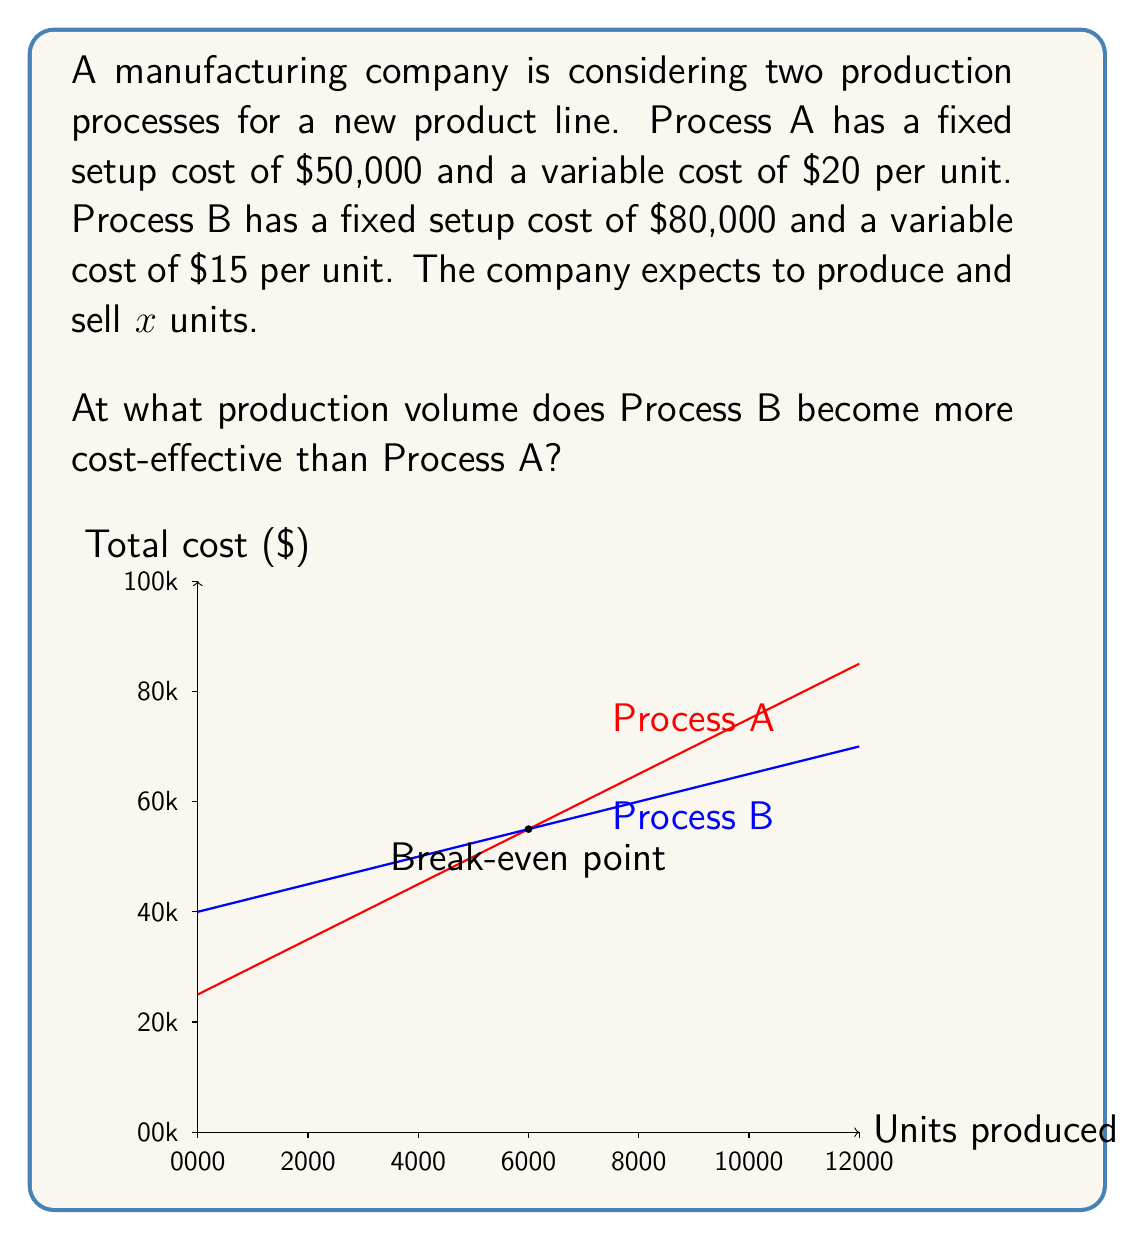What is the answer to this math problem? To solve this problem, we need to find the point where the total costs of both processes are equal. Let's approach this step-by-step:

1) Let's define the total cost functions for each process:
   Process A: $T_A(x) = 50000 + 20x$
   Process B: $T_B(x) = 80000 + 15x$

2) At the break-even point, these costs are equal:
   $T_A(x) = T_B(x)$

3) We can set up an equation:
   $50000 + 20x = 80000 + 15x$

4) Subtract 50000 from both sides:
   $20x = 30000 + 15x$

5) Subtract 15x from both sides:
   $5x = 30000$

6) Divide both sides by 5:
   $x = 6000$

7) To verify, let's calculate the total cost at 6000 units for both processes:
   Process A: $50000 + 20(6000) = 170000$
   Process B: $80000 + 15(6000) = 170000$

8) Beyond 6000 units, Process B will be more cost-effective as its lower variable cost will outweigh its higher fixed cost.
Answer: 6000 units 